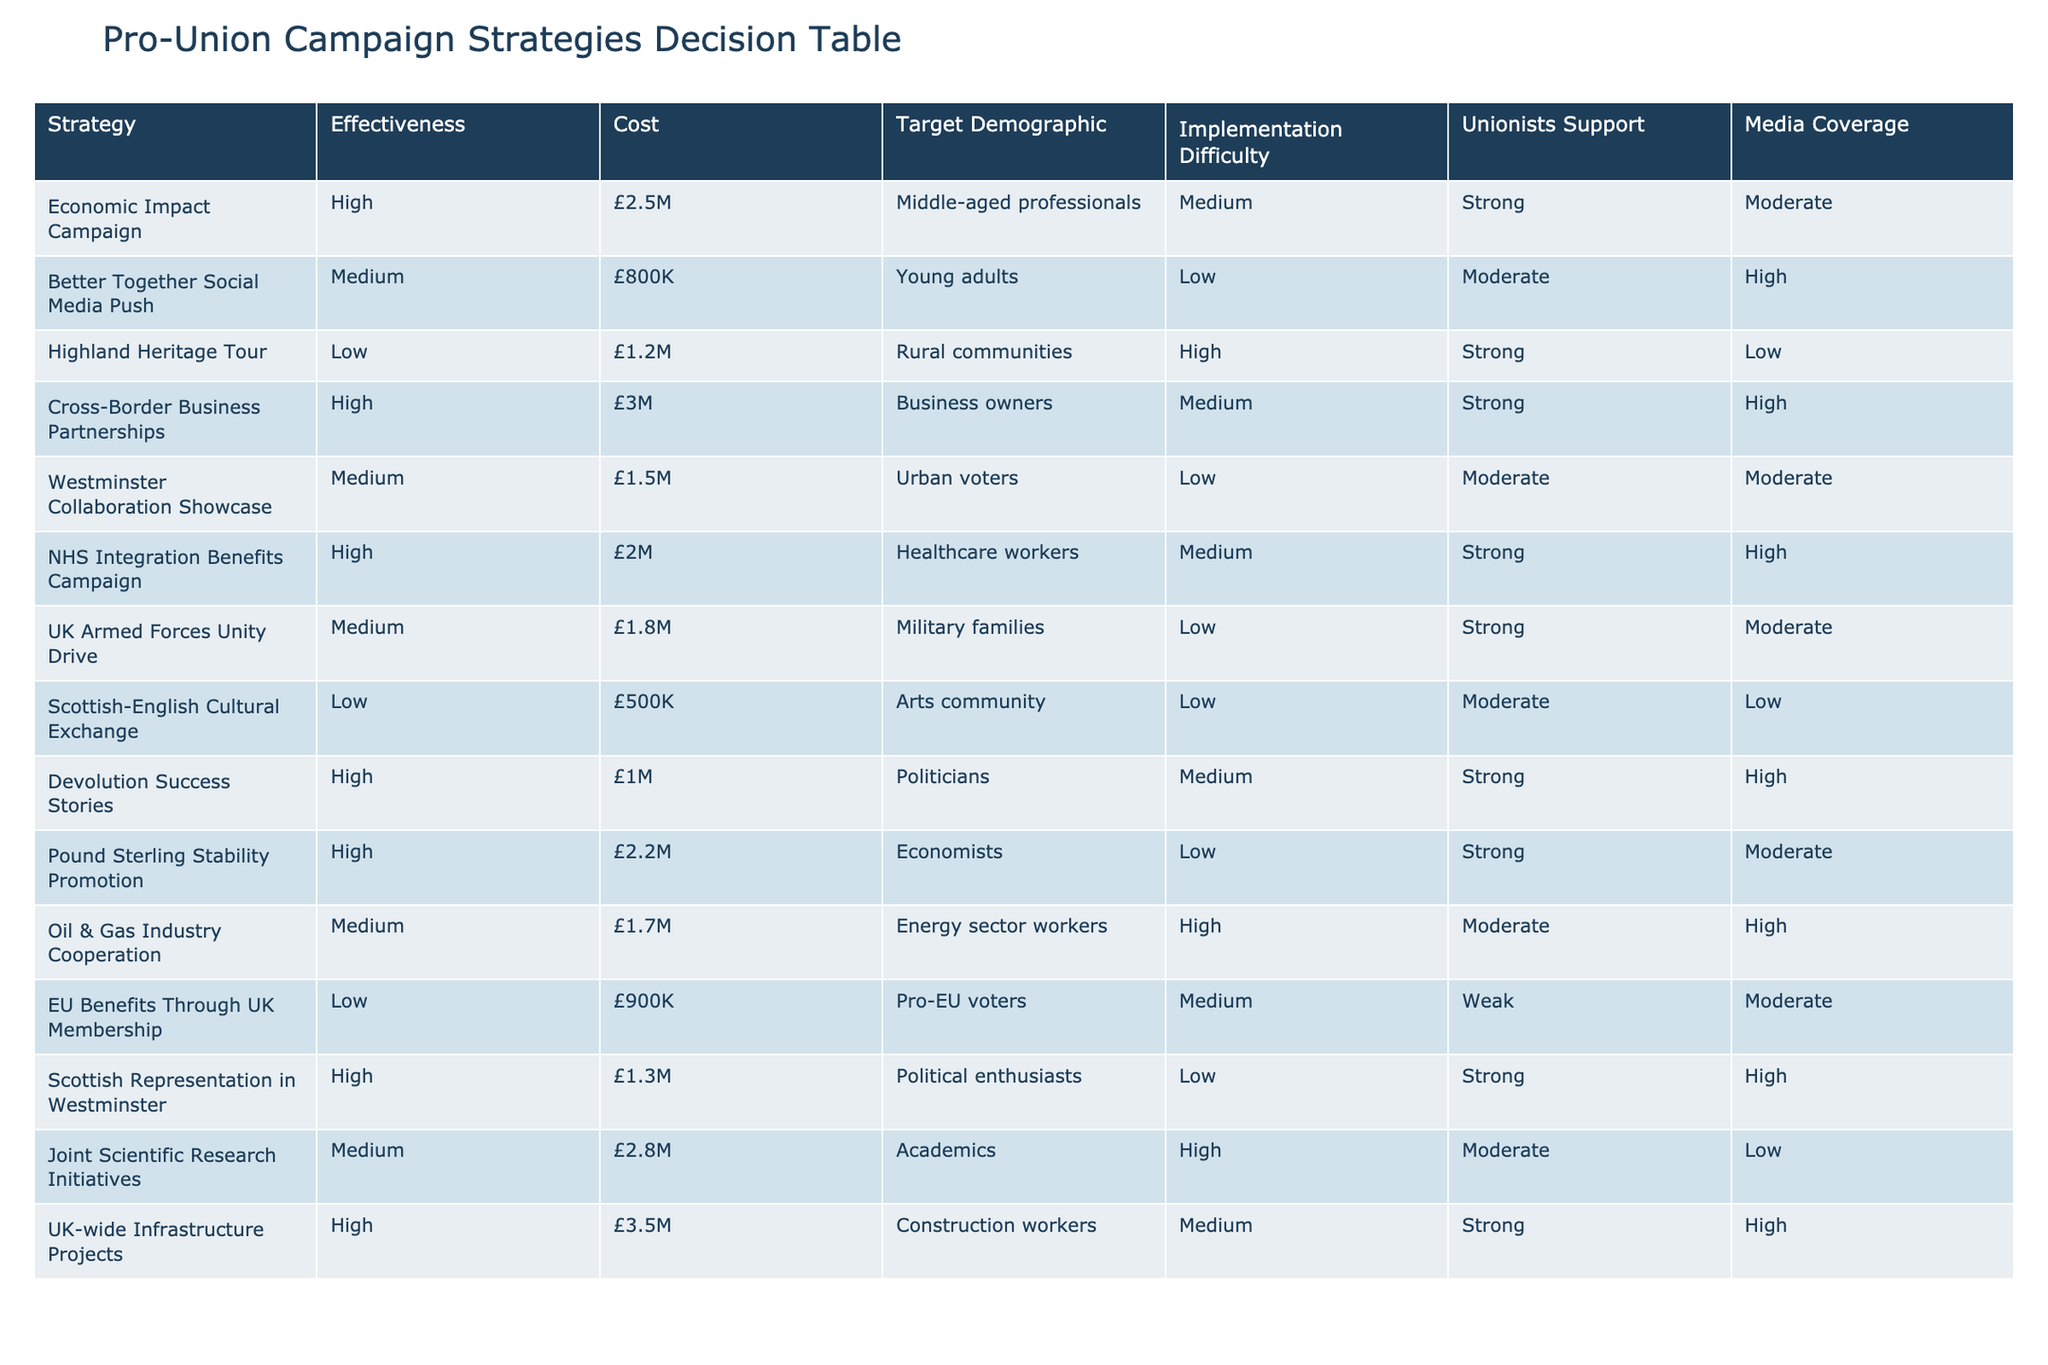What is the effectiveness rating of the "Better Together" Social Media Push strategy? The effectiveness rating is provided directly in the table under the "Effectiveness" column corresponding to the "Better Together" Social Media Push strategy. It shows "Medium".
Answer: Medium Which campaign has the highest cost? The table indicates the costs associated with each campaign. By comparing the costs, the "UK-wide Infrastructure Projects" campaign, with a cost of £3.5M, is identified as the highest.
Answer: £3.5M Is the "Highland Heritage Tour" strategy supported by strong unionist support? The "Highland Heritage Tour" strategy's unionist support is listed under the "Unionists Support" column, where it is marked as "Strong". Thus, it does not fit the inquiry since it shows strong support.
Answer: No What is the average cost of the campaigns with a high effectiveness rating? First, we identify the campaigns with a high effectiveness rating, which are "Economic Impact Campaign", "Cross-Border Business Partnerships", "NHS Integration Benefits Campaign", "Devolution Success Stories", "Pound Sterling Stability Promotion", "Scottish Representation in Westminster", and "UK-wide Infrastructure Projects". Their respective costs are £2.5M, £3M, £2M, £1M, £2.2M, £1.3M, and £3.5M. The total cost is £15.5M, and with 7 campaigns, the average cost is calculated as £15.5M/7 ≈ £2.21M.
Answer: £2.21M Are there any strategies that have low implementation difficulty and are supported by strong unionist support? Analyzing the table for strategies with "Low" implementation difficulty and "Strong" unionist support, we find "UK Armed Forces Unity Drive" fits the criteria. Thus, the answer is affirmative.
Answer: Yes What strategy has the highest effectiveness rating targeting rural communities? The effectiveness rating for the "Highland Heritage Tour," while specifically targeting rural communities, is "Low", indicating it is not high. Other campaigns targeting rural voters did not represent high effectiveness, thus making it the only one in that demographic category and affirming its status despite the low rating.
Answer: Low How many campaigns have media coverage rated as high? By checking the "Media Coverage" column for high ratings, the campaigns "Better Together" Social Media Push, "NHS Integration Benefits Campaign," "Cross-Border Business Partnerships," and "Oil & Gas Industry Cooperation" show high coverage. Counting these gives a total of 4.
Answer: 4 Which strategy has both a medium effectiveness rating and high media coverage? We look for strategies that are rated as "Medium" for effectiveness and have a "High" rating in media coverage. From the table, the "Better Together" Social Media Push and "Oil & Gas Industry Cooperation" fulfill both criteria. Therefore, there are 2 strategies matching this.
Answer: 2 